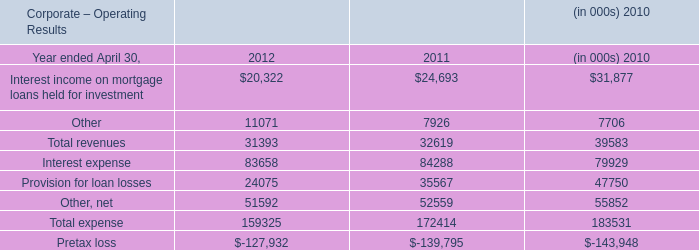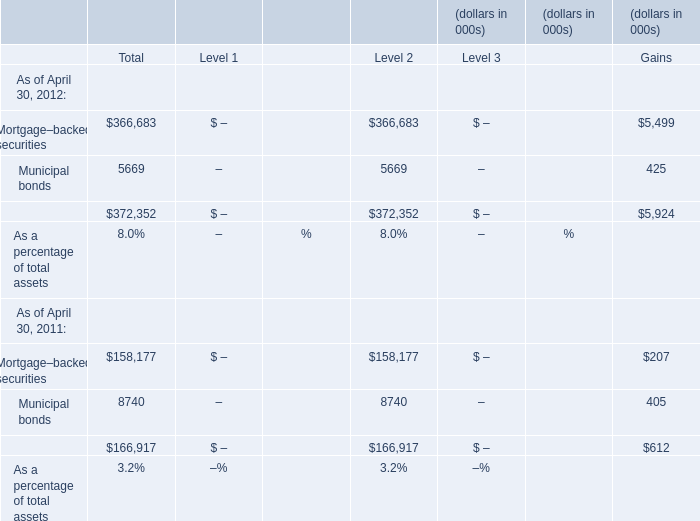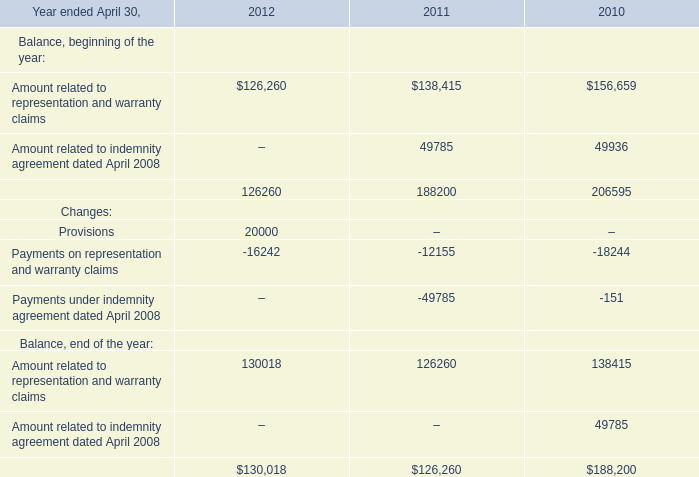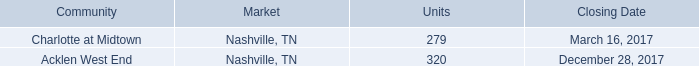during the year ended december 31 , 2017 , what was the ratio of the units disposed to the units acquired 
Computations: (1760 / (279 + 320))
Answer: 2.93823. 